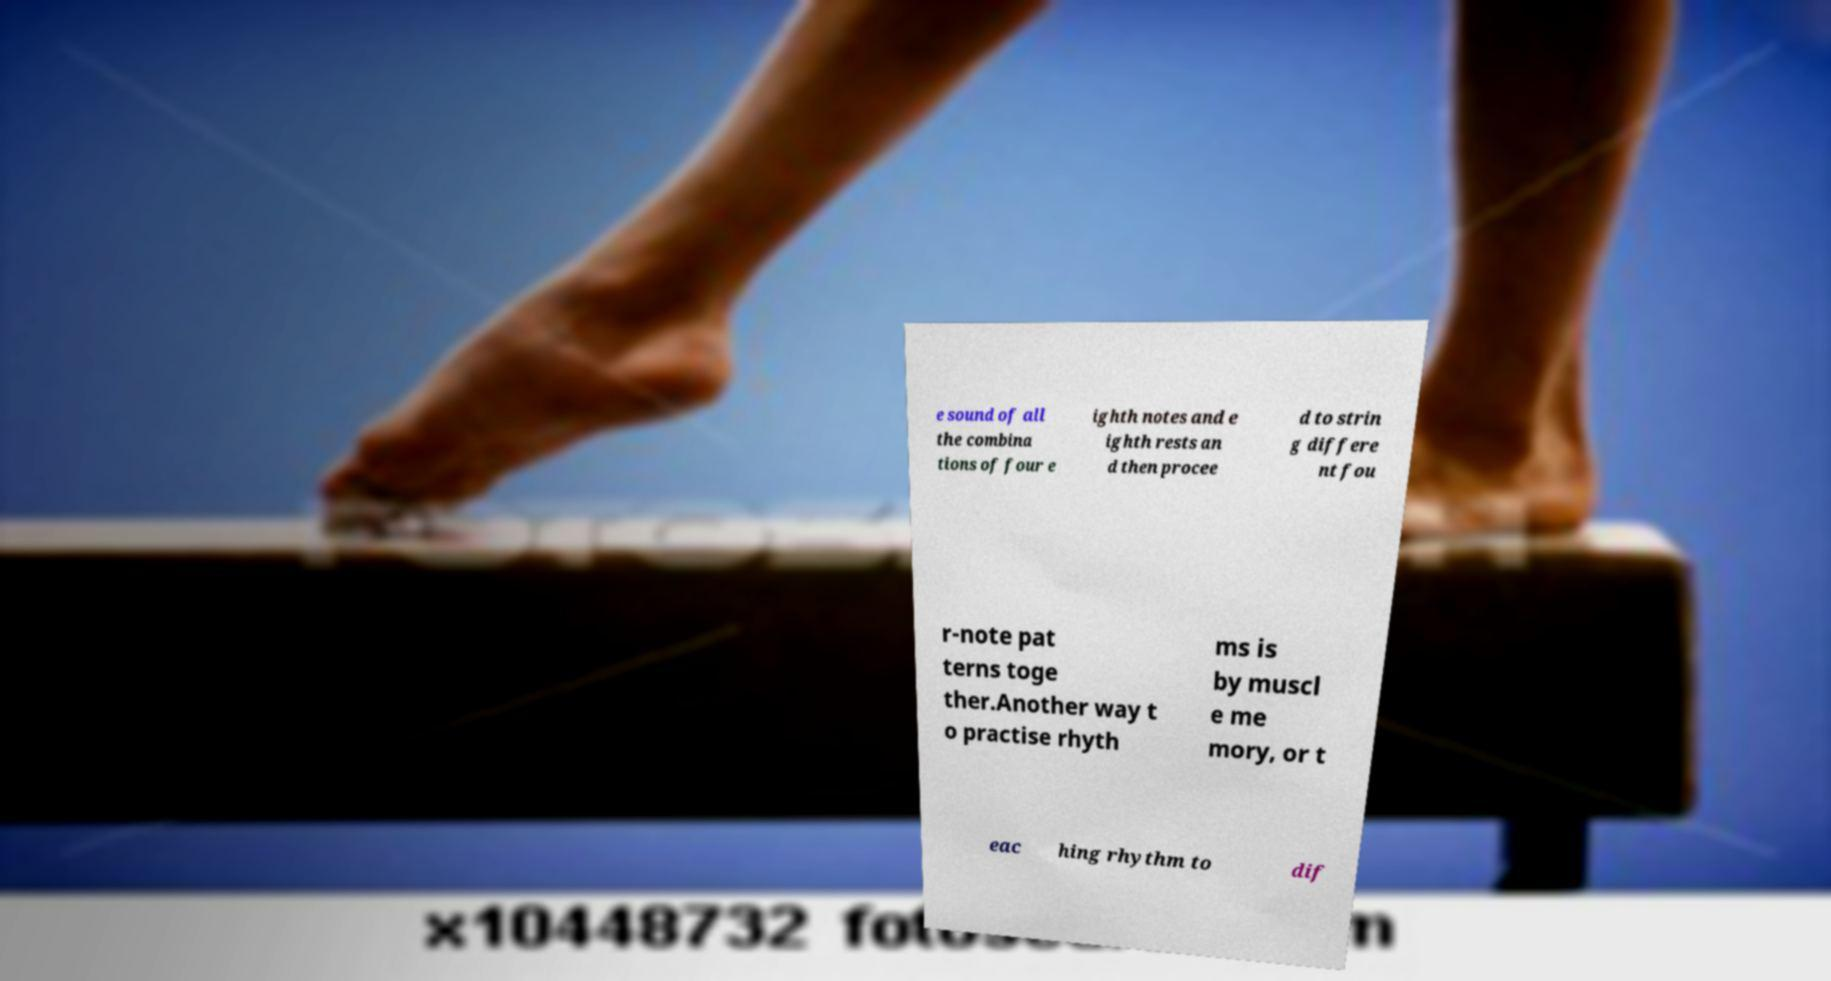I need the written content from this picture converted into text. Can you do that? e sound of all the combina tions of four e ighth notes and e ighth rests an d then procee d to strin g differe nt fou r-note pat terns toge ther.Another way t o practise rhyth ms is by muscl e me mory, or t eac hing rhythm to dif 